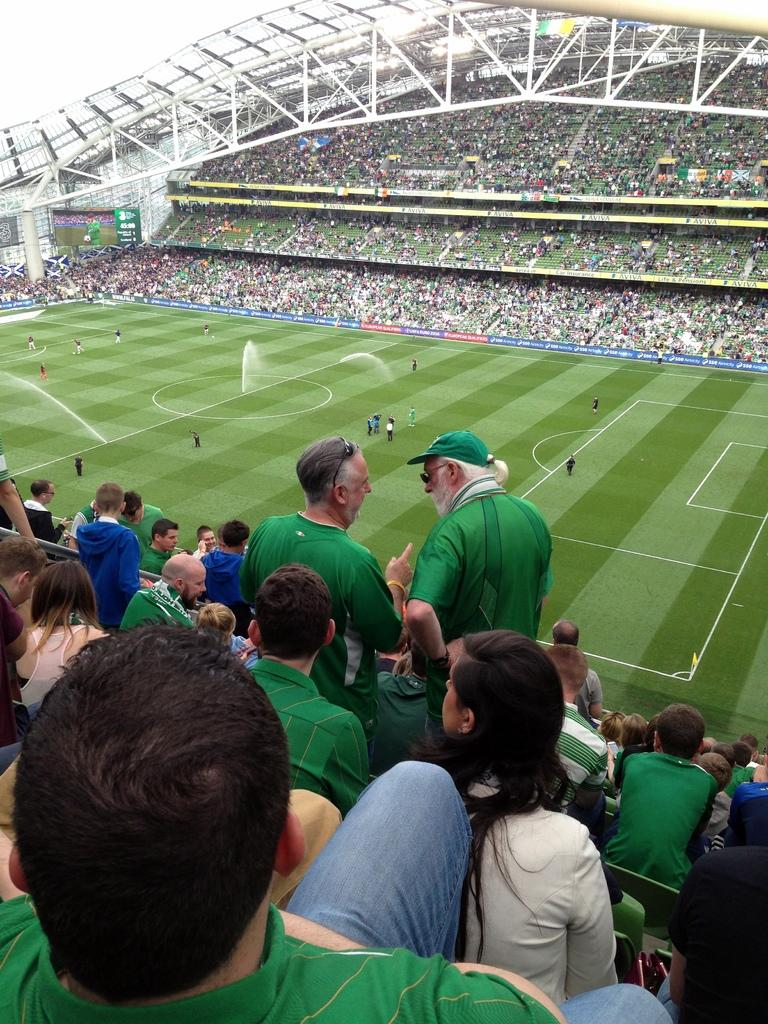What is happening in the image? There are players on the ground, and spectators are watching the game in the stands on either side of the ground. Can you describe the players in the image? The players are on the ground, presumably playing a sport or game. What are the spectators doing in the image? The spectators are watching the game from the stands on either side of the ground. What type of haircut is the plantation receiving in the image? There is no plantation or haircut present in the image. What kind of test is being conducted on the players in the image? There is no test being conducted on the players in the image; they are simply playing a game. 